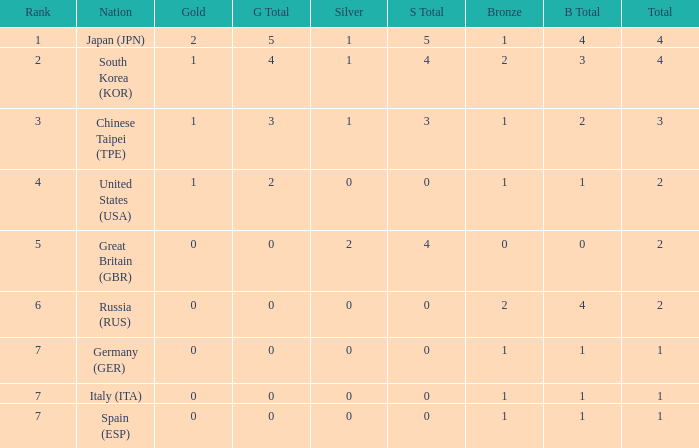What is the rank of the country with more than 2 medals, and 2 gold medals? 1.0. 